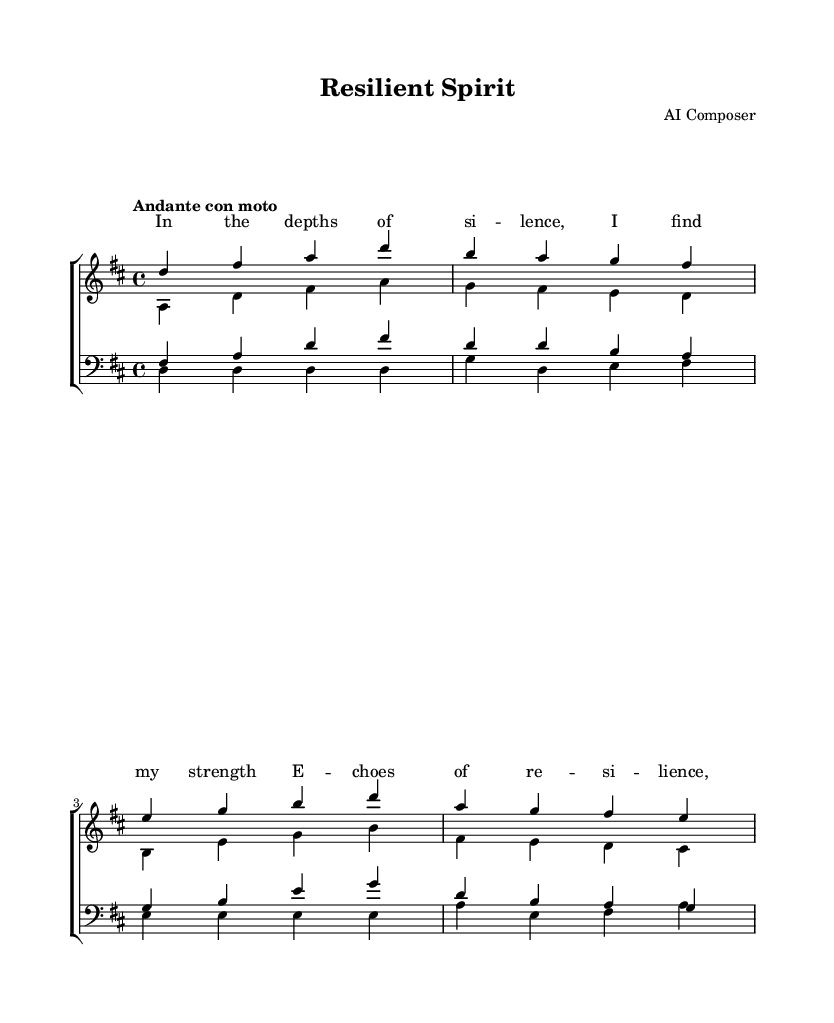What is the key signature of this music? The key signature appears to have two sharps, which indicates that it is in the key of D major.
Answer: D major What is the time signature of this music? The time signature is indicated at the beginning of the score, showing four beats per measure, thus it is 4/4.
Answer: 4/4 What is the tempo marking of this piece? The tempo marking "Andante con moto" suggests a moderately slow tempo with a slight increase in speed.
Answer: Andante con moto How many voices are in the women's section? The women's section has two distinct voices, sopranos and altos, as seen in the respective staves.
Answer: Two What is the first note of the soprano part? The first note of the soprano part is D, which is indicated as the relative pitch in the provided staff.
Answer: D Describe the lyric theme expressed in the verse. The verse speaks of inner strength and resilience found in silence, suggesting a theme of empowerment.
Answer: Empowerment How many measures are present in the bass music? The bass music consists of a total of four measures, as counted from the notation in the bass staff.
Answer: Four 